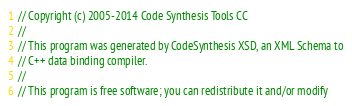Convert code to text. <code><loc_0><loc_0><loc_500><loc_500><_C++_>// Copyright (c) 2005-2014 Code Synthesis Tools CC
//
// This program was generated by CodeSynthesis XSD, an XML Schema to
// C++ data binding compiler.
//
// This program is free software; you can redistribute it and/or modify</code> 